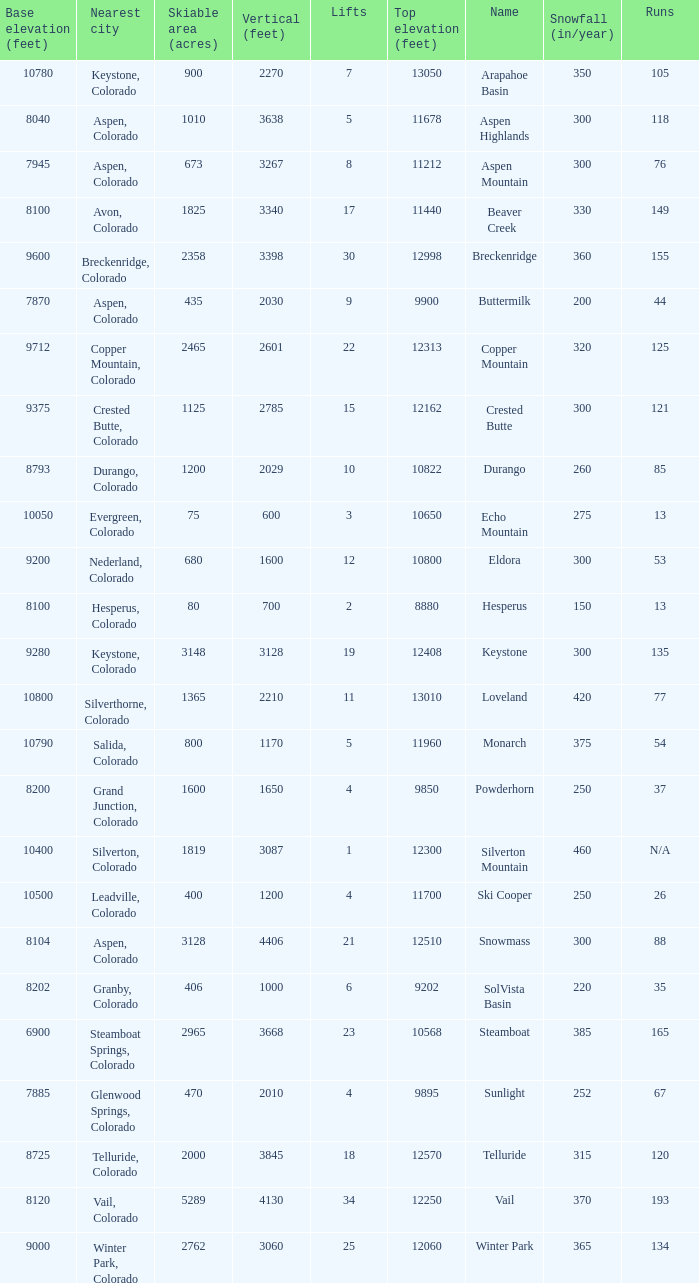How many resorts have 118 runs? 1.0. 